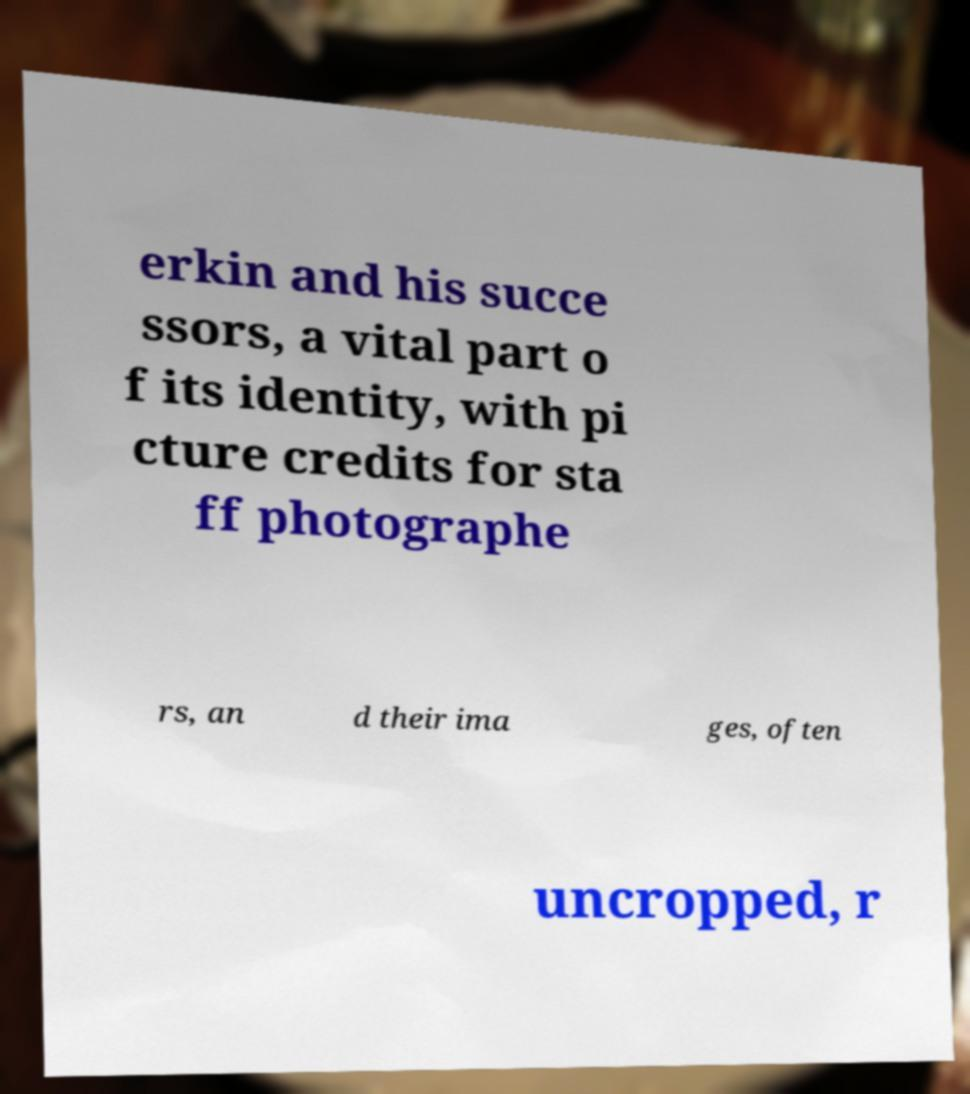For documentation purposes, I need the text within this image transcribed. Could you provide that? erkin and his succe ssors, a vital part o f its identity, with pi cture credits for sta ff photographe rs, an d their ima ges, often uncropped, r 